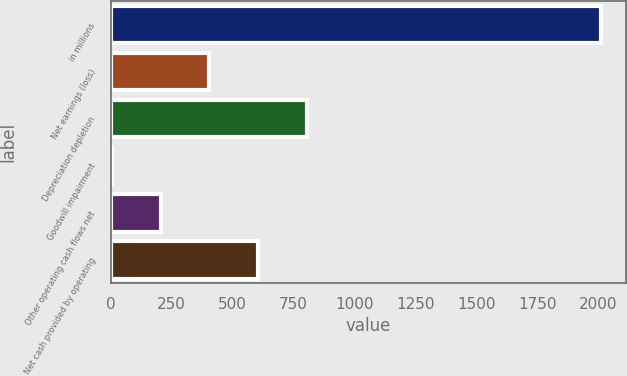Convert chart to OTSL. <chart><loc_0><loc_0><loc_500><loc_500><bar_chart><fcel>in millions<fcel>Net earnings (loss)<fcel>Depreciation depletion<fcel>Goodwill impairment<fcel>Other operating cash flows net<fcel>Net cash provided by operating<nl><fcel>2010<fcel>405.22<fcel>806.42<fcel>4.02<fcel>204.62<fcel>605.82<nl></chart> 